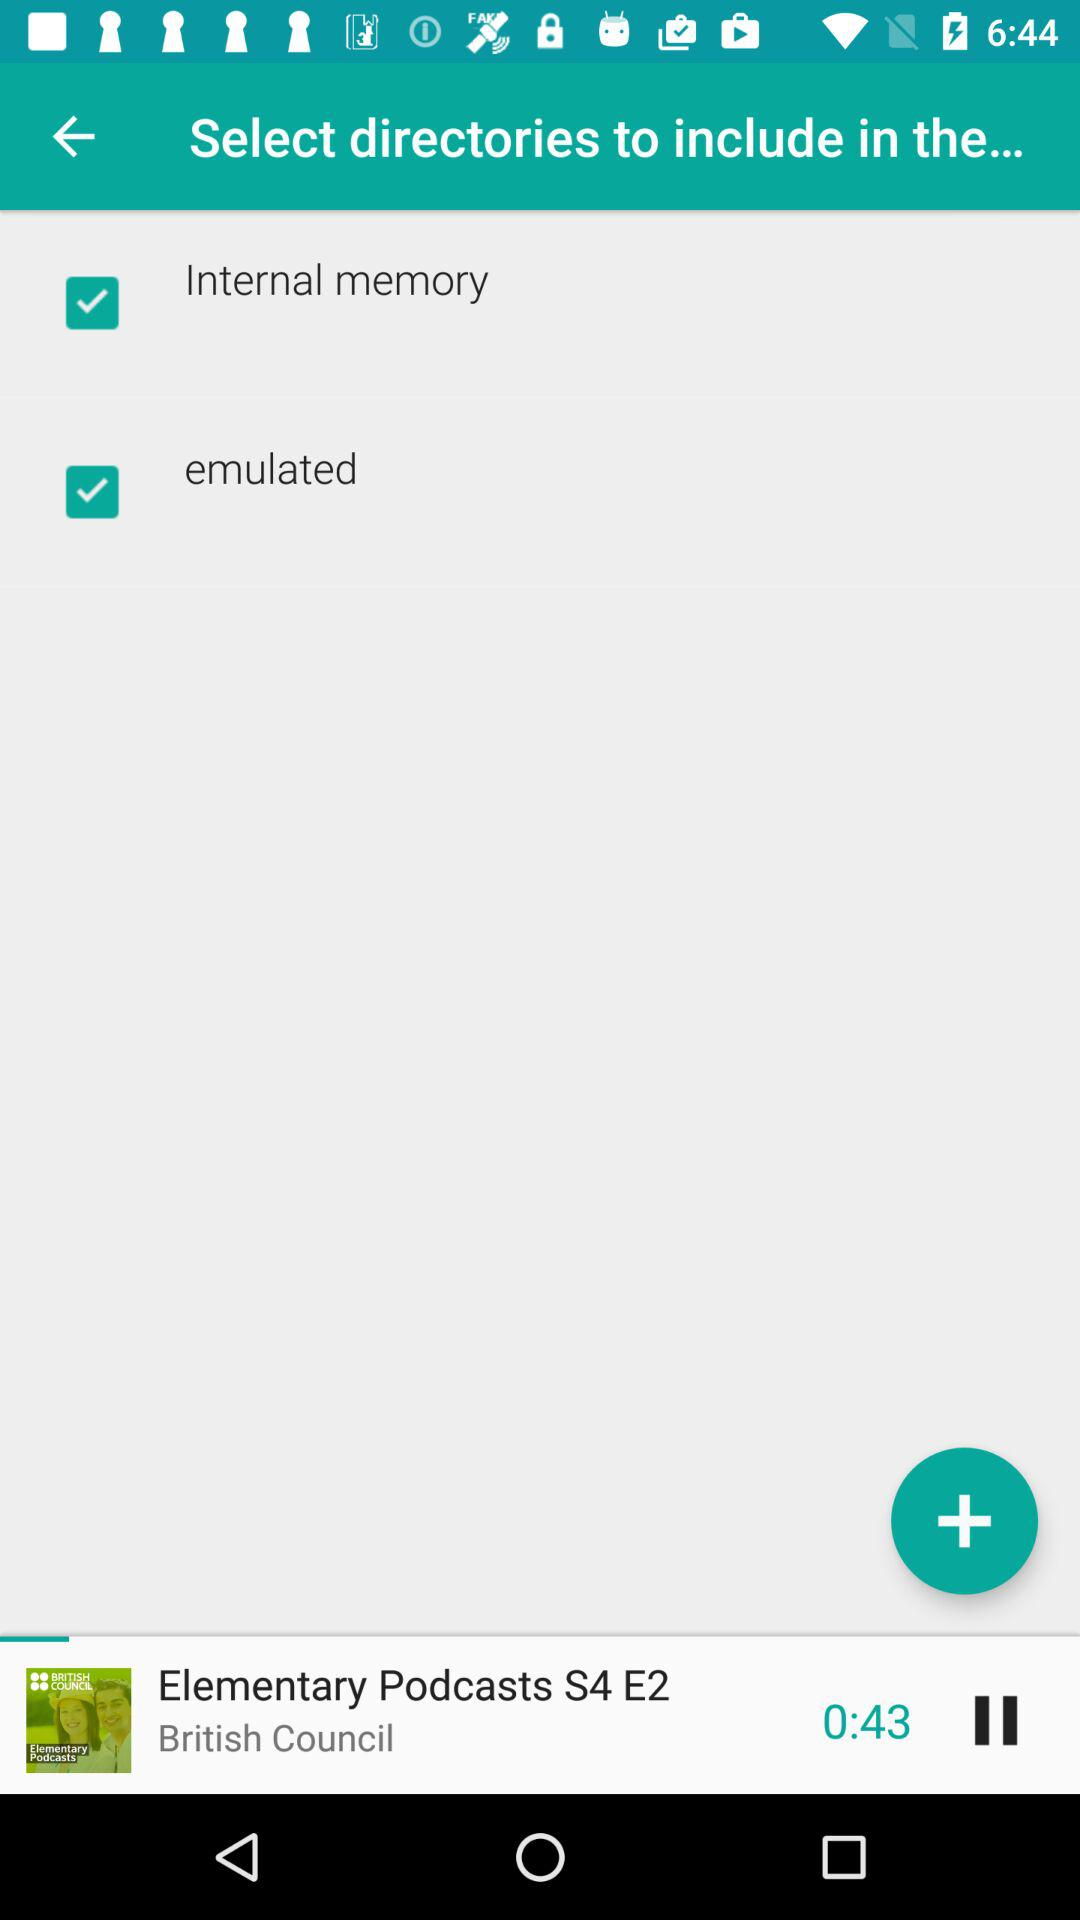What is the title of the podcast? The title of the podcast is "Elementary Podcasts". 